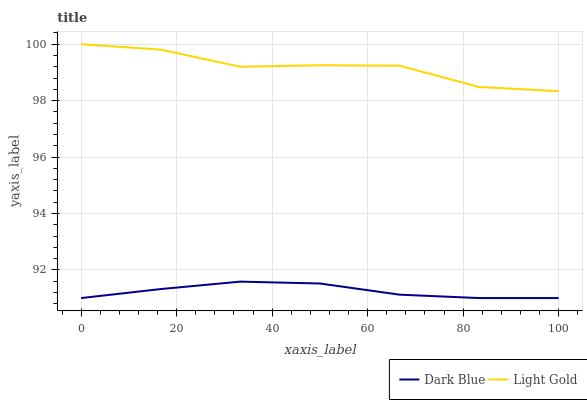Does Light Gold have the minimum area under the curve?
Answer yes or no. No. Is Light Gold the smoothest?
Answer yes or no. No. Does Light Gold have the lowest value?
Answer yes or no. No. Is Dark Blue less than Light Gold?
Answer yes or no. Yes. Is Light Gold greater than Dark Blue?
Answer yes or no. Yes. Does Dark Blue intersect Light Gold?
Answer yes or no. No. 